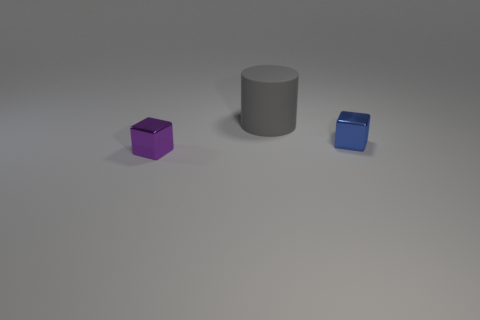Add 3 red blocks. How many objects exist? 6 Subtract 1 cubes. How many cubes are left? 1 Subtract all blocks. How many objects are left? 1 Subtract all cyan cubes. Subtract all yellow balls. How many cubes are left? 2 Subtract all green cylinders. How many purple cubes are left? 1 Subtract all big purple cubes. Subtract all gray things. How many objects are left? 2 Add 1 big matte cylinders. How many big matte cylinders are left? 2 Add 1 brown rubber blocks. How many brown rubber blocks exist? 1 Subtract 1 purple blocks. How many objects are left? 2 